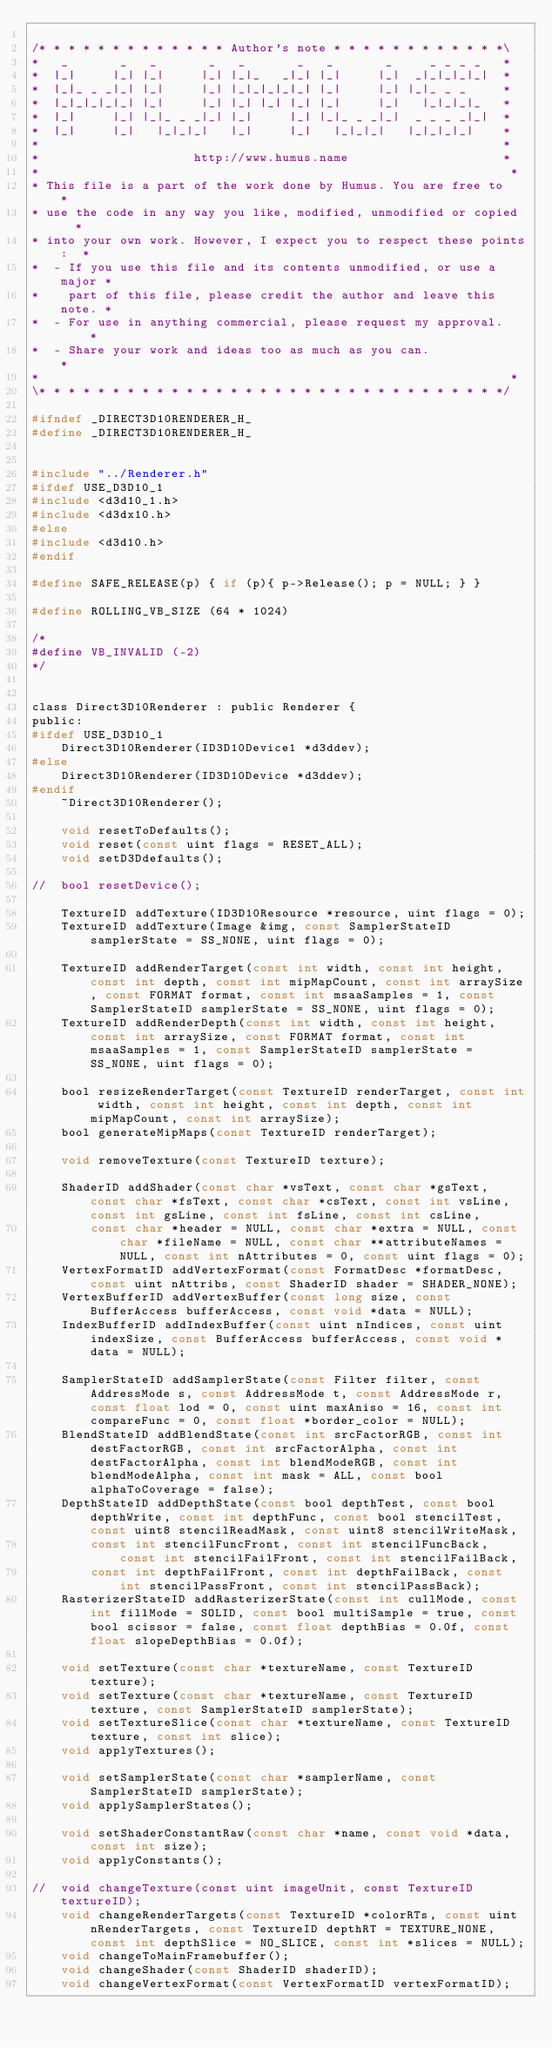<code> <loc_0><loc_0><loc_500><loc_500><_C_>
/* * * * * * * * * * * * * Author's note * * * * * * * * * * * *\
*   _       _   _       _   _       _   _       _     _ _ _ _   *
*  |_|     |_| |_|     |_| |_|_   _|_| |_|     |_|  _|_|_|_|_|  *
*  |_|_ _ _|_| |_|     |_| |_|_|_|_|_| |_|     |_| |_|_ _ _     *
*  |_|_|_|_|_| |_|     |_| |_| |_| |_| |_|     |_|   |_|_|_|_   *
*  |_|     |_| |_|_ _ _|_| |_|     |_| |_|_ _ _|_|  _ _ _ _|_|  *
*  |_|     |_|   |_|_|_|   |_|     |_|   |_|_|_|   |_|_|_|_|    *
*                                                               *
*                     http://www.humus.name                     *
*                                                                *
* This file is a part of the work done by Humus. You are free to   *
* use the code in any way you like, modified, unmodified or copied   *
* into your own work. However, I expect you to respect these points:  *
*  - If you use this file and its contents unmodified, or use a major *
*    part of this file, please credit the author and leave this note. *
*  - For use in anything commercial, please request my approval.     *
*  - Share your work and ideas too as much as you can.             *
*                                                                *
\* * * * * * * * * * * * * * * * * * * * * * * * * * * * * * * */

#ifndef _DIRECT3D10RENDERER_H_
#define _DIRECT3D10RENDERER_H_


#include "../Renderer.h"
#ifdef USE_D3D10_1
#include <d3d10_1.h>
#include <d3dx10.h>
#else
#include <d3d10.h>
#endif

#define SAFE_RELEASE(p) { if (p){ p->Release(); p = NULL; } }

#define ROLLING_VB_SIZE (64 * 1024)

/*
#define VB_INVALID (-2)
*/


class Direct3D10Renderer : public Renderer {
public:
#ifdef USE_D3D10_1
	Direct3D10Renderer(ID3D10Device1 *d3ddev);
#else
	Direct3D10Renderer(ID3D10Device *d3ddev);
#endif
	~Direct3D10Renderer();

	void resetToDefaults();
	void reset(const uint flags = RESET_ALL);
	void setD3Ddefaults();

//	bool resetDevice();

	TextureID addTexture(ID3D10Resource *resource, uint flags = 0);
	TextureID addTexture(Image &img, const SamplerStateID samplerState = SS_NONE, uint flags = 0);

	TextureID addRenderTarget(const int width, const int height, const int depth, const int mipMapCount, const int arraySize, const FORMAT format, const int msaaSamples = 1, const SamplerStateID samplerState = SS_NONE, uint flags = 0);
	TextureID addRenderDepth(const int width, const int height, const int arraySize, const FORMAT format, const int msaaSamples = 1, const SamplerStateID samplerState = SS_NONE, uint flags = 0);

	bool resizeRenderTarget(const TextureID renderTarget, const int width, const int height, const int depth, const int mipMapCount, const int arraySize);
	bool generateMipMaps(const TextureID renderTarget);

	void removeTexture(const TextureID texture);

	ShaderID addShader(const char *vsText, const char *gsText, const char *fsText, const char *csText, const int vsLine, const int gsLine, const int fsLine, const int csLine,
		const char *header = NULL, const char *extra = NULL, const char *fileName = NULL, const char **attributeNames = NULL, const int nAttributes = 0, const uint flags = 0);
	VertexFormatID addVertexFormat(const FormatDesc *formatDesc, const uint nAttribs, const ShaderID shader = SHADER_NONE);
	VertexBufferID addVertexBuffer(const long size, const BufferAccess bufferAccess, const void *data = NULL);
	IndexBufferID addIndexBuffer(const uint nIndices, const uint indexSize, const BufferAccess bufferAccess, const void *data = NULL);

	SamplerStateID addSamplerState(const Filter filter, const AddressMode s, const AddressMode t, const AddressMode r, const float lod = 0, const uint maxAniso = 16, const int compareFunc = 0, const float *border_color = NULL);
	BlendStateID addBlendState(const int srcFactorRGB, const int destFactorRGB, const int srcFactorAlpha, const int destFactorAlpha, const int blendModeRGB, const int blendModeAlpha, const int mask = ALL, const bool alphaToCoverage = false);
	DepthStateID addDepthState(const bool depthTest, const bool depthWrite, const int depthFunc, const bool stencilTest, const uint8 stencilReadMask, const uint8 stencilWriteMask,
		const int stencilFuncFront, const int stencilFuncBack, const int stencilFailFront, const int stencilFailBack,
		const int depthFailFront, const int depthFailBack, const int stencilPassFront, const int stencilPassBack);
	RasterizerStateID addRasterizerState(const int cullMode, const int fillMode = SOLID, const bool multiSample = true, const bool scissor = false, const float depthBias = 0.0f, const float slopeDepthBias = 0.0f);

	void setTexture(const char *textureName, const TextureID texture);
	void setTexture(const char *textureName, const TextureID texture, const SamplerStateID samplerState);
	void setTextureSlice(const char *textureName, const TextureID texture, const int slice);
	void applyTextures();

	void setSamplerState(const char *samplerName, const SamplerStateID samplerState);
	void applySamplerStates();

	void setShaderConstantRaw(const char *name, const void *data, const int size);
	void applyConstants();

//	void changeTexture(const uint imageUnit, const TextureID textureID);
	void changeRenderTargets(const TextureID *colorRTs, const uint nRenderTargets, const TextureID depthRT = TEXTURE_NONE, const int depthSlice = NO_SLICE, const int *slices = NULL);
	void changeToMainFramebuffer();
	void changeShader(const ShaderID shaderID);
	void changeVertexFormat(const VertexFormatID vertexFormatID);</code> 